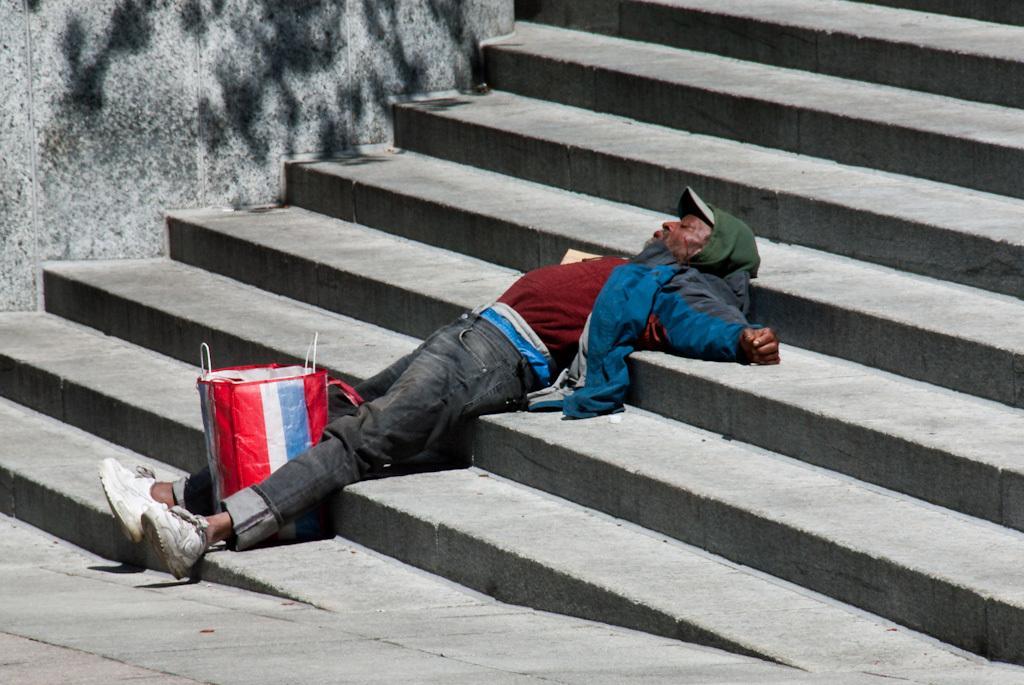Can you describe this image briefly? In this image there is a man lying on steps, in the middle of his legs there is a bag, in the background there is a wall. 